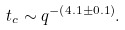Convert formula to latex. <formula><loc_0><loc_0><loc_500><loc_500>t _ { c } \sim q ^ { - \left ( 4 . 1 \pm 0 . 1 \right ) } .</formula> 